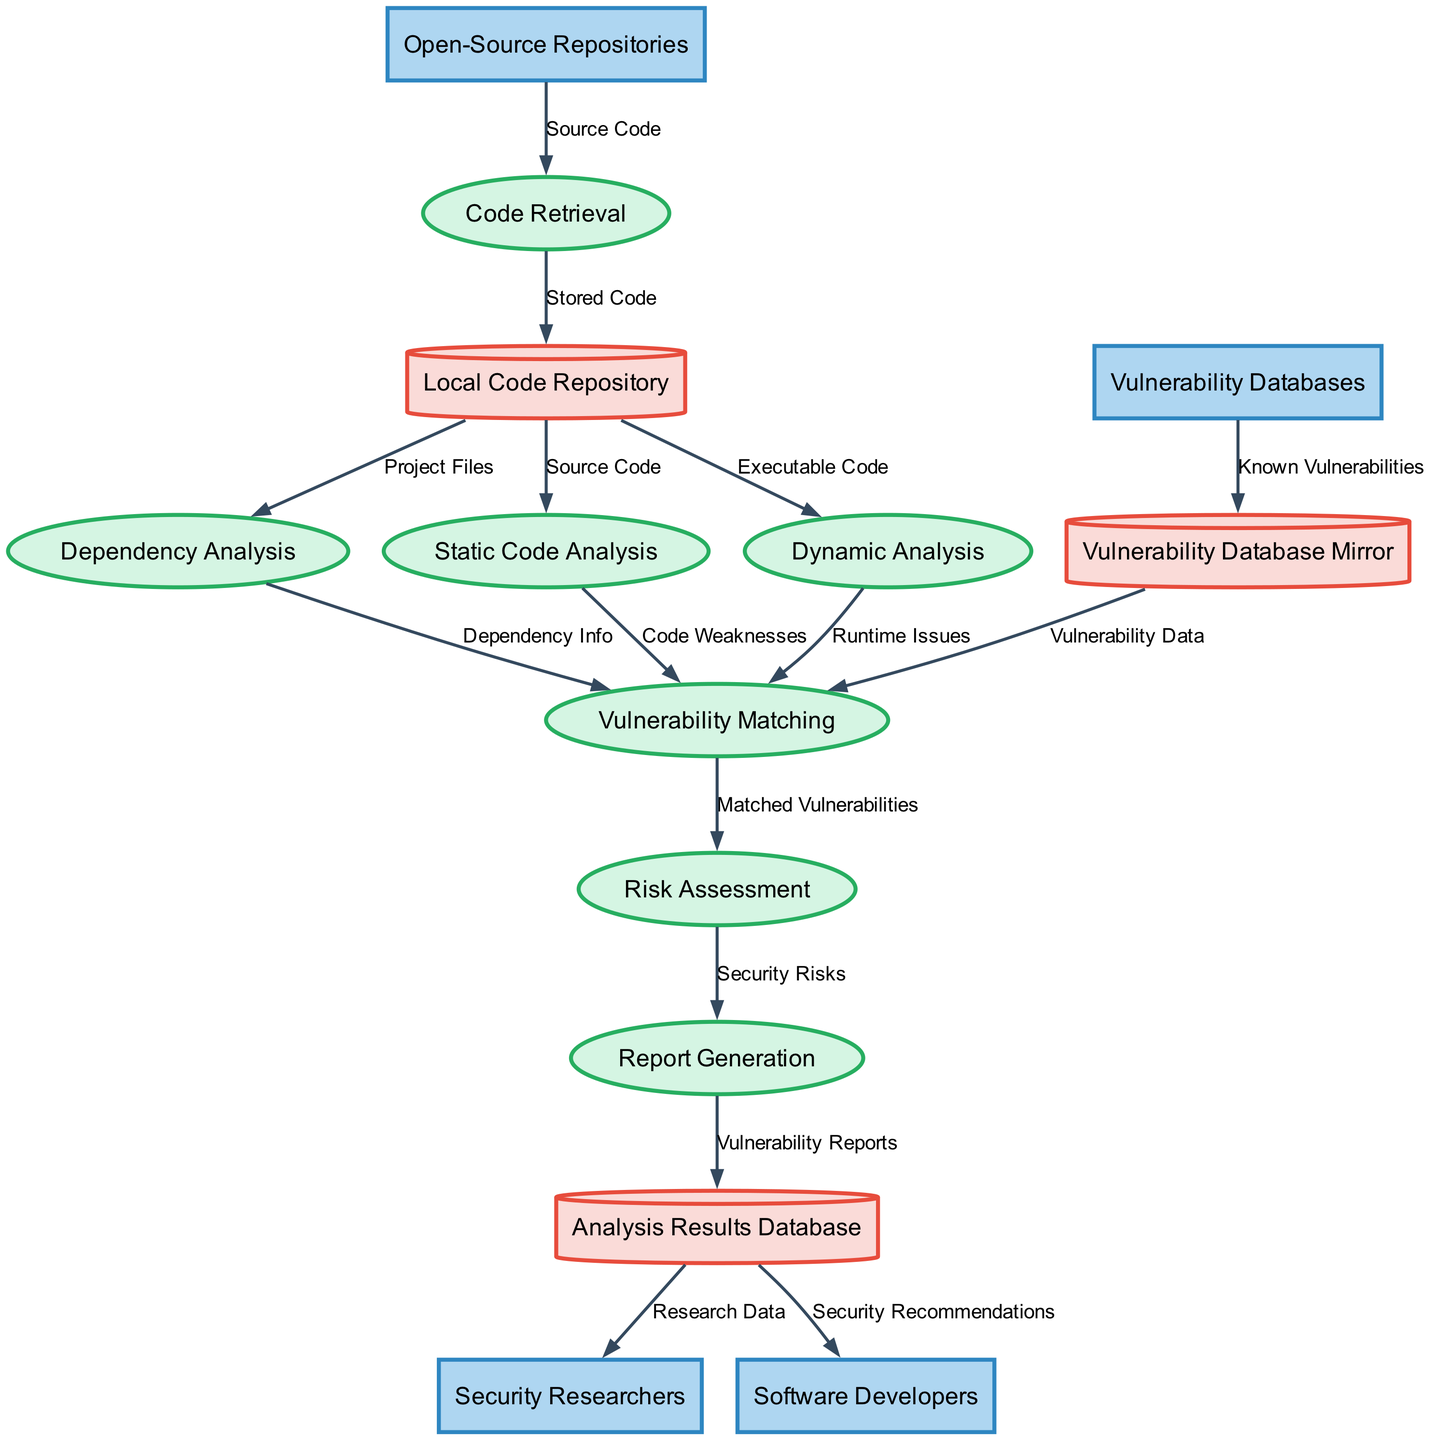What are the external entities involved in the diagram? The external entities can be found at the beginning of the diagram, listed separately from the processes and data stores, showing all entities contributing to the vulnerability scanning process. They are Open-Source Repositories, Vulnerability Databases, Security Researchers, and Software Developers.
Answer: Open-Source Repositories, Vulnerability Databases, Security Researchers, Software Developers How many processes are defined in the diagram? By counting the processes listed in the diagram, we find there are seven distinct processes. Each process specifies a step in the vulnerability scanning workflow.
Answer: Seven What type of data is transferred from the Local Code Repository to the Dependency Analysis? The diagram indicates that Project Files are sent from the Local Code Repository to the Dependency Analysis, specifying the kind of data being passed.
Answer: Project Files Which process receives input from both Vulnerability Database Mirror and Dependency Analysis? Investigating the flows, it is evident that the Vulnerability Matching process collects input data from both the Vulnerability Database Mirror and Dependency Analysis, highlighting the integration of multiple data sources for vulnerability identification.
Answer: Vulnerability Matching What is the final data store where vulnerability reports are stored? Following the flow, the last data store indicated in the diagram for storing output from the Report Generation process is the Analysis Results Database. This represents the storage of organized reports that can be used for further analysis.
Answer: Analysis Results Database What type of analysis follows the Static Code Analysis in the process sequence? The diagram shows the sequence of processes, and right after the Static Code Analysis, we see Dynamic Analysis occurring next, indicating a progression from static to runtime analysis of the code.
Answer: Dynamic Analysis What flow connects Risk Assessment to Report Generation? The flow from Risk Assessment to Report Generation is labeled "Security Risks," indicating that the assessment of risks is directly used to generate reports, tying these two processes together in the workflow.
Answer: Security Risks How many distinct data stores are used in the diagram? Counting the data stores outlined in the diagram reveals three unique data stores utilized throughout the vulnerability scanning process. This reflects how data is organized and stored at various stages.
Answer: Three 